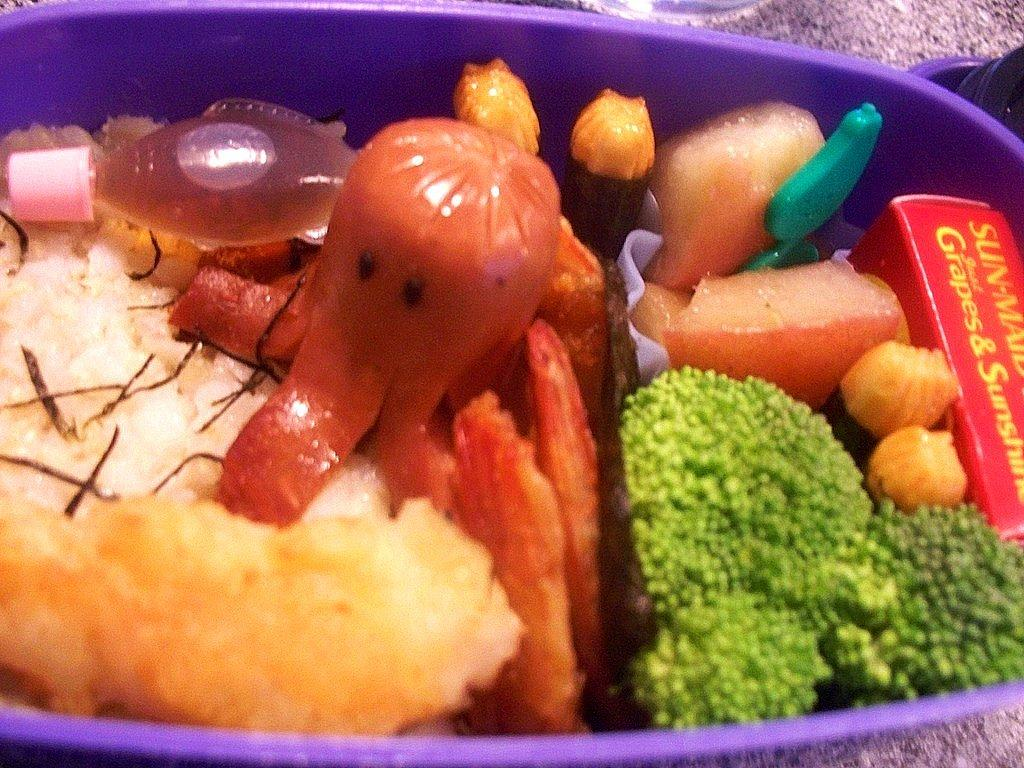What type of food is in the plastic box in the image? There is rice, fruit pieces, and broccoli pieces in the plastic box. What is the plastic box placed on in the image? The plastic box is kept on a marble table. What type of muscle can be seen flexing in the image? There is no muscle visible in the image; it features a plastic box with food items on a marble table. 